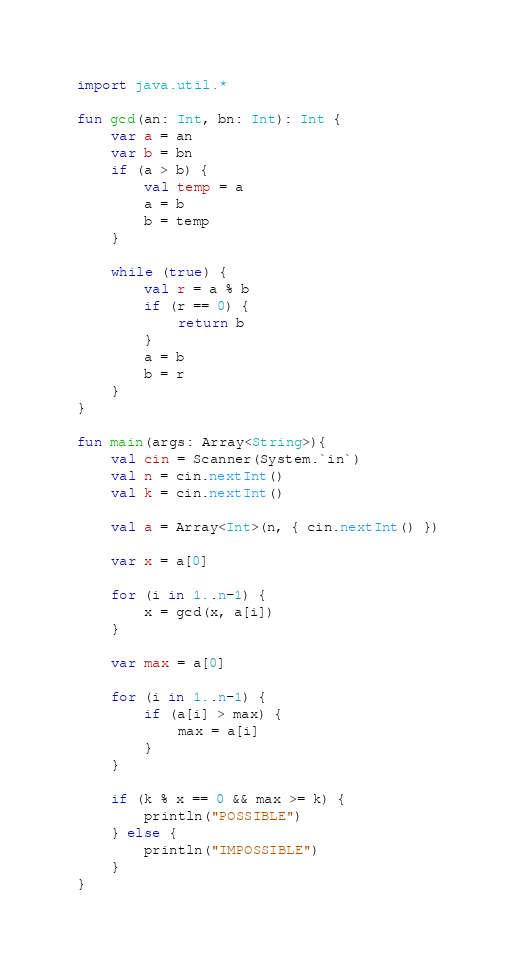<code> <loc_0><loc_0><loc_500><loc_500><_Kotlin_>import java.util.*

fun gcd(an: Int, bn: Int): Int {
    var a = an
    var b = bn
    if (a > b) {
        val temp = a
        a = b
        b = temp
    }

    while (true) {
        val r = a % b
        if (r == 0) {
            return b
        }
        a = b
        b = r
    }
}

fun main(args: Array<String>){
	val cin = Scanner(System.`in`)
    val n = cin.nextInt()
    val k = cin.nextInt()
    
    val a = Array<Int>(n, { cin.nextInt() })

    var x = a[0]

    for (i in 1..n-1) {
        x = gcd(x, a[i])
    }

    var max = a[0]

    for (i in 1..n-1) {
        if (a[i] > max) {
            max = a[i]
        }
    }

    if (k % x == 0 && max >= k) {
        println("POSSIBLE")
    } else {
        println("IMPOSSIBLE")
    }
}</code> 